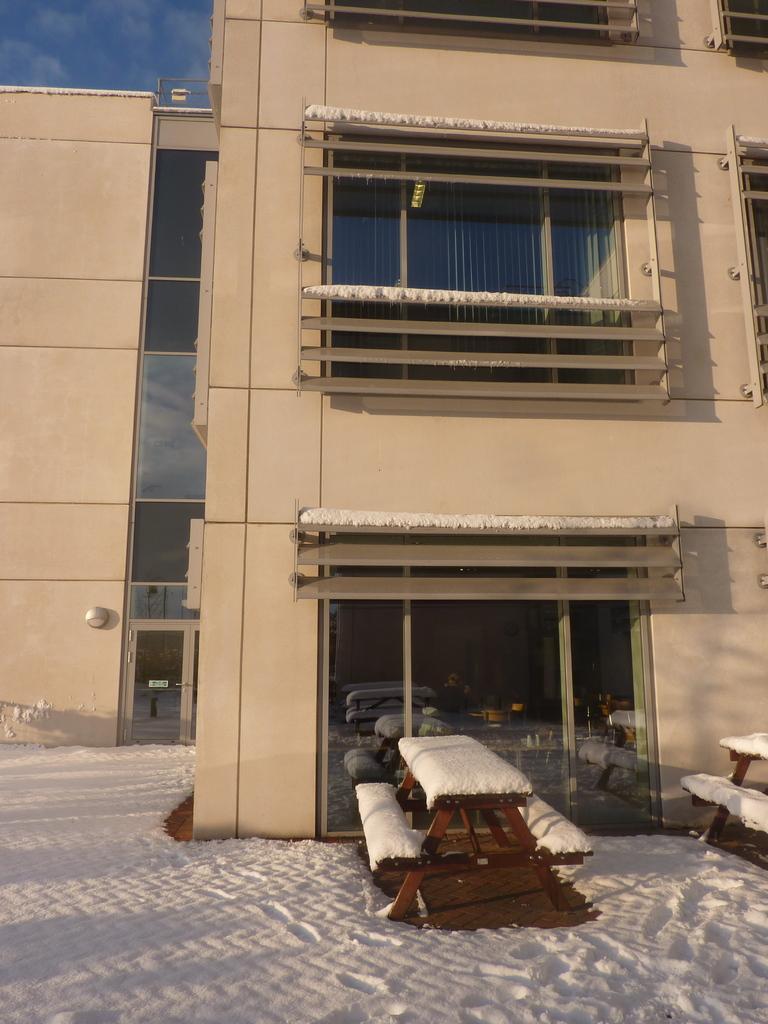Can you describe this image briefly? In the picture we can see the building with glass windows and near it, we can see the snow surface with two benches and on the top of the building we can see the sky with clouds. 